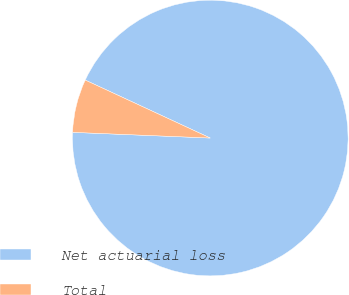Convert chart to OTSL. <chart><loc_0><loc_0><loc_500><loc_500><pie_chart><fcel>Net actuarial loss<fcel>Total<nl><fcel>93.75%<fcel>6.25%<nl></chart> 